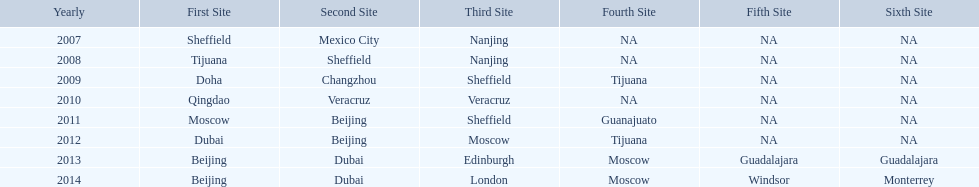Could you parse the entire table? {'header': ['Yearly', 'First Site', 'Second Site', 'Third Site', 'Fourth Site', 'Fifth Site', 'Sixth Site'], 'rows': [['2007', 'Sheffield', 'Mexico City', 'Nanjing', 'NA', 'NA', 'NA'], ['2008', 'Tijuana', 'Sheffield', 'Nanjing', 'NA', 'NA', 'NA'], ['2009', 'Doha', 'Changzhou', 'Sheffield', 'Tijuana', 'NA', 'NA'], ['2010', 'Qingdao', 'Veracruz', 'Veracruz', 'NA', 'NA', 'NA'], ['2011', 'Moscow', 'Beijing', 'Sheffield', 'Guanajuato', 'NA', 'NA'], ['2012', 'Dubai', 'Beijing', 'Moscow', 'Tijuana', 'NA', 'NA'], ['2013', 'Beijing', 'Dubai', 'Edinburgh', 'Moscow', 'Guadalajara', 'Guadalajara'], ['2014', 'Beijing', 'Dubai', 'London', 'Moscow', 'Windsor', 'Monterrey']]} Which year had more venues, 2007 or 2012? 2012. 